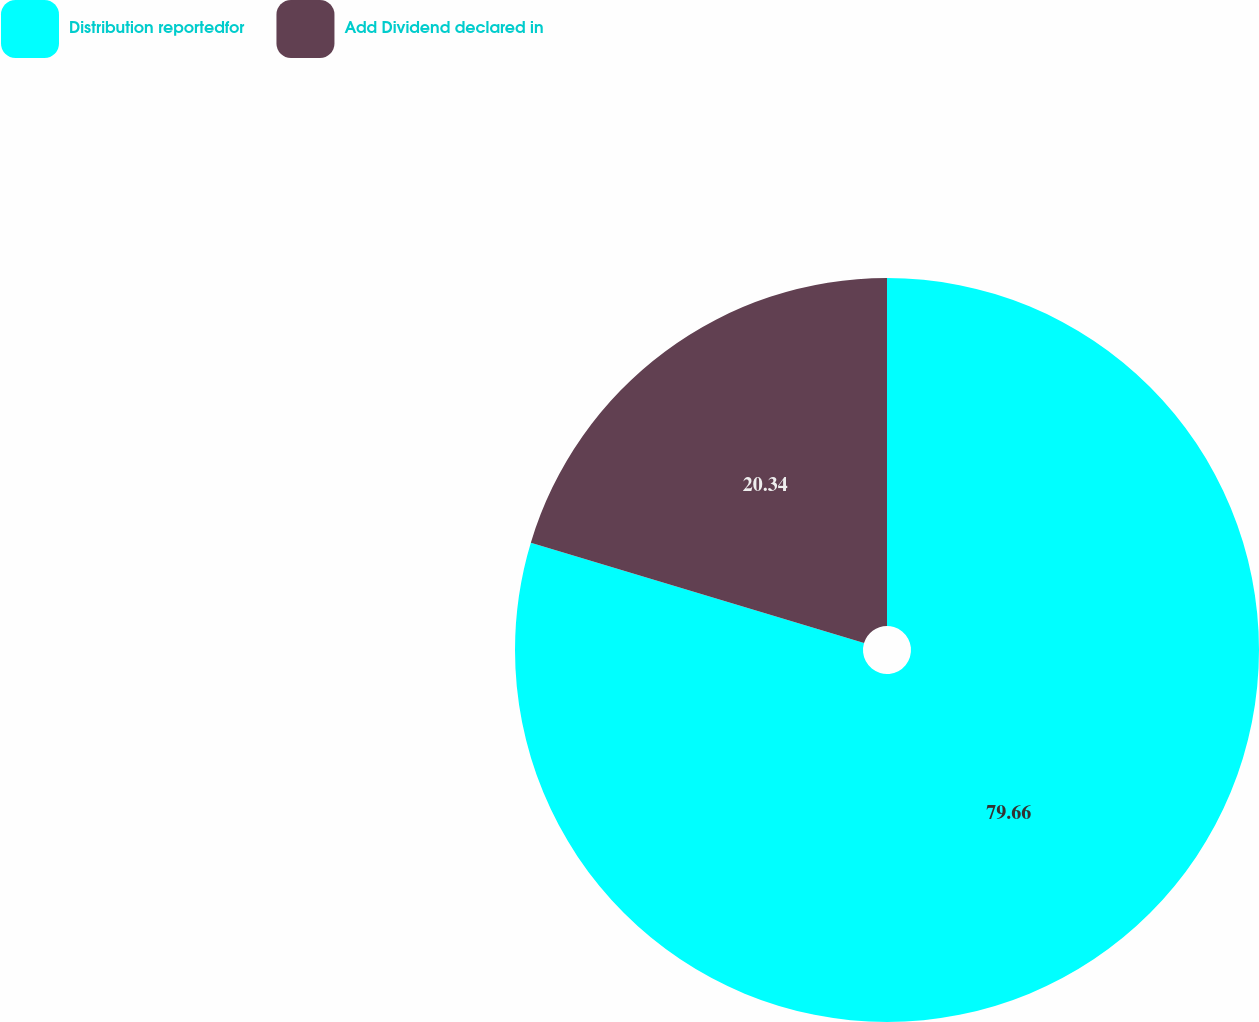<chart> <loc_0><loc_0><loc_500><loc_500><pie_chart><fcel>Distribution reportedfor<fcel>Add Dividend declared in<nl><fcel>79.66%<fcel>20.34%<nl></chart> 